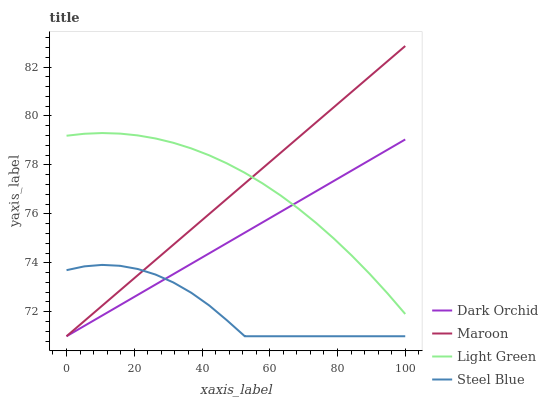Does Steel Blue have the minimum area under the curve?
Answer yes or no. Yes. Does Light Green have the maximum area under the curve?
Answer yes or no. Yes. Does Maroon have the minimum area under the curve?
Answer yes or no. No. Does Maroon have the maximum area under the curve?
Answer yes or no. No. Is Maroon the smoothest?
Answer yes or no. Yes. Is Steel Blue the roughest?
Answer yes or no. Yes. Is Dark Orchid the smoothest?
Answer yes or no. No. Is Dark Orchid the roughest?
Answer yes or no. No. Does Maroon have the highest value?
Answer yes or no. Yes. Does Dark Orchid have the highest value?
Answer yes or no. No. Is Steel Blue less than Light Green?
Answer yes or no. Yes. Is Light Green greater than Steel Blue?
Answer yes or no. Yes. Does Dark Orchid intersect Light Green?
Answer yes or no. Yes. Is Dark Orchid less than Light Green?
Answer yes or no. No. Is Dark Orchid greater than Light Green?
Answer yes or no. No. Does Steel Blue intersect Light Green?
Answer yes or no. No. 